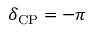Convert formula to latex. <formula><loc_0><loc_0><loc_500><loc_500>\delta _ { C P } = - \pi</formula> 